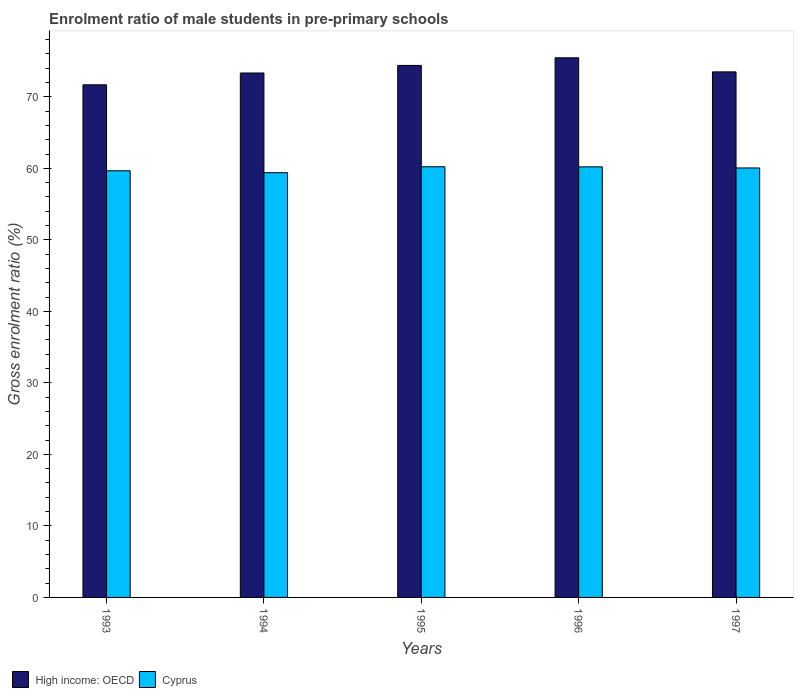Are the number of bars per tick equal to the number of legend labels?
Give a very brief answer. Yes. How many bars are there on the 3rd tick from the right?
Provide a succinct answer. 2. What is the label of the 4th group of bars from the left?
Keep it short and to the point. 1996. In how many cases, is the number of bars for a given year not equal to the number of legend labels?
Your answer should be very brief. 0. What is the enrolment ratio of male students in pre-primary schools in High income: OECD in 1996?
Ensure brevity in your answer.  75.45. Across all years, what is the maximum enrolment ratio of male students in pre-primary schools in Cyprus?
Your answer should be compact. 60.22. Across all years, what is the minimum enrolment ratio of male students in pre-primary schools in Cyprus?
Offer a very short reply. 59.39. In which year was the enrolment ratio of male students in pre-primary schools in Cyprus minimum?
Give a very brief answer. 1994. What is the total enrolment ratio of male students in pre-primary schools in High income: OECD in the graph?
Your answer should be very brief. 368.33. What is the difference between the enrolment ratio of male students in pre-primary schools in Cyprus in 1994 and that in 1995?
Your answer should be compact. -0.83. What is the difference between the enrolment ratio of male students in pre-primary schools in High income: OECD in 1996 and the enrolment ratio of male students in pre-primary schools in Cyprus in 1994?
Your answer should be compact. 16.07. What is the average enrolment ratio of male students in pre-primary schools in High income: OECD per year?
Ensure brevity in your answer.  73.67. In the year 1993, what is the difference between the enrolment ratio of male students in pre-primary schools in Cyprus and enrolment ratio of male students in pre-primary schools in High income: OECD?
Keep it short and to the point. -12.02. In how many years, is the enrolment ratio of male students in pre-primary schools in Cyprus greater than 62 %?
Provide a succinct answer. 0. What is the ratio of the enrolment ratio of male students in pre-primary schools in High income: OECD in 1994 to that in 1995?
Provide a short and direct response. 0.99. Is the enrolment ratio of male students in pre-primary schools in Cyprus in 1993 less than that in 1996?
Offer a terse response. Yes. Is the difference between the enrolment ratio of male students in pre-primary schools in Cyprus in 1994 and 1996 greater than the difference between the enrolment ratio of male students in pre-primary schools in High income: OECD in 1994 and 1996?
Give a very brief answer. Yes. What is the difference between the highest and the second highest enrolment ratio of male students in pre-primary schools in Cyprus?
Provide a succinct answer. 0.01. What is the difference between the highest and the lowest enrolment ratio of male students in pre-primary schools in High income: OECD?
Provide a short and direct response. 3.77. What does the 1st bar from the left in 1993 represents?
Ensure brevity in your answer.  High income: OECD. What does the 2nd bar from the right in 1993 represents?
Keep it short and to the point. High income: OECD. How many bars are there?
Offer a terse response. 10. Are all the bars in the graph horizontal?
Your answer should be compact. No. What is the difference between two consecutive major ticks on the Y-axis?
Offer a very short reply. 10. Does the graph contain any zero values?
Offer a very short reply. No. Does the graph contain grids?
Give a very brief answer. No. Where does the legend appear in the graph?
Your answer should be very brief. Bottom left. How many legend labels are there?
Keep it short and to the point. 2. What is the title of the graph?
Offer a terse response. Enrolment ratio of male students in pre-primary schools. Does "Samoa" appear as one of the legend labels in the graph?
Give a very brief answer. No. What is the Gross enrolment ratio (%) in High income: OECD in 1993?
Provide a short and direct response. 71.68. What is the Gross enrolment ratio (%) of Cyprus in 1993?
Give a very brief answer. 59.66. What is the Gross enrolment ratio (%) in High income: OECD in 1994?
Your answer should be compact. 73.33. What is the Gross enrolment ratio (%) of Cyprus in 1994?
Ensure brevity in your answer.  59.39. What is the Gross enrolment ratio (%) in High income: OECD in 1995?
Keep it short and to the point. 74.39. What is the Gross enrolment ratio (%) in Cyprus in 1995?
Your answer should be compact. 60.22. What is the Gross enrolment ratio (%) of High income: OECD in 1996?
Provide a succinct answer. 75.45. What is the Gross enrolment ratio (%) of Cyprus in 1996?
Your answer should be compact. 60.2. What is the Gross enrolment ratio (%) in High income: OECD in 1997?
Your answer should be compact. 73.49. What is the Gross enrolment ratio (%) of Cyprus in 1997?
Keep it short and to the point. 60.05. Across all years, what is the maximum Gross enrolment ratio (%) of High income: OECD?
Provide a short and direct response. 75.45. Across all years, what is the maximum Gross enrolment ratio (%) in Cyprus?
Make the answer very short. 60.22. Across all years, what is the minimum Gross enrolment ratio (%) in High income: OECD?
Give a very brief answer. 71.68. Across all years, what is the minimum Gross enrolment ratio (%) in Cyprus?
Make the answer very short. 59.39. What is the total Gross enrolment ratio (%) in High income: OECD in the graph?
Your answer should be compact. 368.33. What is the total Gross enrolment ratio (%) of Cyprus in the graph?
Your response must be concise. 299.51. What is the difference between the Gross enrolment ratio (%) of High income: OECD in 1993 and that in 1994?
Your answer should be very brief. -1.65. What is the difference between the Gross enrolment ratio (%) of Cyprus in 1993 and that in 1994?
Your response must be concise. 0.27. What is the difference between the Gross enrolment ratio (%) in High income: OECD in 1993 and that in 1995?
Keep it short and to the point. -2.71. What is the difference between the Gross enrolment ratio (%) in Cyprus in 1993 and that in 1995?
Your answer should be compact. -0.56. What is the difference between the Gross enrolment ratio (%) in High income: OECD in 1993 and that in 1996?
Make the answer very short. -3.77. What is the difference between the Gross enrolment ratio (%) of Cyprus in 1993 and that in 1996?
Ensure brevity in your answer.  -0.55. What is the difference between the Gross enrolment ratio (%) in High income: OECD in 1993 and that in 1997?
Provide a succinct answer. -1.81. What is the difference between the Gross enrolment ratio (%) of Cyprus in 1993 and that in 1997?
Your answer should be very brief. -0.39. What is the difference between the Gross enrolment ratio (%) of High income: OECD in 1994 and that in 1995?
Provide a short and direct response. -1.06. What is the difference between the Gross enrolment ratio (%) of Cyprus in 1994 and that in 1995?
Provide a short and direct response. -0.83. What is the difference between the Gross enrolment ratio (%) of High income: OECD in 1994 and that in 1996?
Your answer should be compact. -2.12. What is the difference between the Gross enrolment ratio (%) of Cyprus in 1994 and that in 1996?
Provide a short and direct response. -0.82. What is the difference between the Gross enrolment ratio (%) of High income: OECD in 1994 and that in 1997?
Give a very brief answer. -0.16. What is the difference between the Gross enrolment ratio (%) of Cyprus in 1994 and that in 1997?
Your answer should be compact. -0.66. What is the difference between the Gross enrolment ratio (%) in High income: OECD in 1995 and that in 1996?
Ensure brevity in your answer.  -1.06. What is the difference between the Gross enrolment ratio (%) of Cyprus in 1995 and that in 1996?
Make the answer very short. 0.01. What is the difference between the Gross enrolment ratio (%) in High income: OECD in 1995 and that in 1997?
Ensure brevity in your answer.  0.9. What is the difference between the Gross enrolment ratio (%) of Cyprus in 1995 and that in 1997?
Keep it short and to the point. 0.17. What is the difference between the Gross enrolment ratio (%) in High income: OECD in 1996 and that in 1997?
Provide a succinct answer. 1.97. What is the difference between the Gross enrolment ratio (%) of Cyprus in 1996 and that in 1997?
Provide a succinct answer. 0.15. What is the difference between the Gross enrolment ratio (%) of High income: OECD in 1993 and the Gross enrolment ratio (%) of Cyprus in 1994?
Offer a very short reply. 12.29. What is the difference between the Gross enrolment ratio (%) of High income: OECD in 1993 and the Gross enrolment ratio (%) of Cyprus in 1995?
Your answer should be very brief. 11.46. What is the difference between the Gross enrolment ratio (%) of High income: OECD in 1993 and the Gross enrolment ratio (%) of Cyprus in 1996?
Your answer should be compact. 11.47. What is the difference between the Gross enrolment ratio (%) of High income: OECD in 1993 and the Gross enrolment ratio (%) of Cyprus in 1997?
Make the answer very short. 11.63. What is the difference between the Gross enrolment ratio (%) in High income: OECD in 1994 and the Gross enrolment ratio (%) in Cyprus in 1995?
Make the answer very short. 13.11. What is the difference between the Gross enrolment ratio (%) of High income: OECD in 1994 and the Gross enrolment ratio (%) of Cyprus in 1996?
Ensure brevity in your answer.  13.12. What is the difference between the Gross enrolment ratio (%) of High income: OECD in 1994 and the Gross enrolment ratio (%) of Cyprus in 1997?
Ensure brevity in your answer.  13.28. What is the difference between the Gross enrolment ratio (%) of High income: OECD in 1995 and the Gross enrolment ratio (%) of Cyprus in 1996?
Offer a very short reply. 14.19. What is the difference between the Gross enrolment ratio (%) in High income: OECD in 1995 and the Gross enrolment ratio (%) in Cyprus in 1997?
Your answer should be very brief. 14.34. What is the difference between the Gross enrolment ratio (%) of High income: OECD in 1996 and the Gross enrolment ratio (%) of Cyprus in 1997?
Your response must be concise. 15.4. What is the average Gross enrolment ratio (%) of High income: OECD per year?
Make the answer very short. 73.67. What is the average Gross enrolment ratio (%) of Cyprus per year?
Make the answer very short. 59.9. In the year 1993, what is the difference between the Gross enrolment ratio (%) in High income: OECD and Gross enrolment ratio (%) in Cyprus?
Provide a succinct answer. 12.02. In the year 1994, what is the difference between the Gross enrolment ratio (%) of High income: OECD and Gross enrolment ratio (%) of Cyprus?
Keep it short and to the point. 13.94. In the year 1995, what is the difference between the Gross enrolment ratio (%) of High income: OECD and Gross enrolment ratio (%) of Cyprus?
Provide a succinct answer. 14.17. In the year 1996, what is the difference between the Gross enrolment ratio (%) in High income: OECD and Gross enrolment ratio (%) in Cyprus?
Provide a short and direct response. 15.25. In the year 1997, what is the difference between the Gross enrolment ratio (%) of High income: OECD and Gross enrolment ratio (%) of Cyprus?
Your answer should be compact. 13.44. What is the ratio of the Gross enrolment ratio (%) of High income: OECD in 1993 to that in 1994?
Offer a terse response. 0.98. What is the ratio of the Gross enrolment ratio (%) in High income: OECD in 1993 to that in 1995?
Provide a short and direct response. 0.96. What is the ratio of the Gross enrolment ratio (%) of High income: OECD in 1993 to that in 1996?
Provide a succinct answer. 0.95. What is the ratio of the Gross enrolment ratio (%) of Cyprus in 1993 to that in 1996?
Give a very brief answer. 0.99. What is the ratio of the Gross enrolment ratio (%) of High income: OECD in 1993 to that in 1997?
Give a very brief answer. 0.98. What is the ratio of the Gross enrolment ratio (%) of Cyprus in 1993 to that in 1997?
Provide a succinct answer. 0.99. What is the ratio of the Gross enrolment ratio (%) of High income: OECD in 1994 to that in 1995?
Ensure brevity in your answer.  0.99. What is the ratio of the Gross enrolment ratio (%) in Cyprus in 1994 to that in 1995?
Offer a terse response. 0.99. What is the ratio of the Gross enrolment ratio (%) in High income: OECD in 1994 to that in 1996?
Offer a very short reply. 0.97. What is the ratio of the Gross enrolment ratio (%) in Cyprus in 1994 to that in 1996?
Offer a terse response. 0.99. What is the ratio of the Gross enrolment ratio (%) of High income: OECD in 1994 to that in 1997?
Provide a succinct answer. 1. What is the ratio of the Gross enrolment ratio (%) of Cyprus in 1994 to that in 1997?
Your response must be concise. 0.99. What is the ratio of the Gross enrolment ratio (%) of High income: OECD in 1995 to that in 1996?
Your answer should be very brief. 0.99. What is the ratio of the Gross enrolment ratio (%) in Cyprus in 1995 to that in 1996?
Make the answer very short. 1. What is the ratio of the Gross enrolment ratio (%) in High income: OECD in 1995 to that in 1997?
Offer a very short reply. 1.01. What is the ratio of the Gross enrolment ratio (%) in Cyprus in 1995 to that in 1997?
Provide a short and direct response. 1. What is the ratio of the Gross enrolment ratio (%) in High income: OECD in 1996 to that in 1997?
Your response must be concise. 1.03. What is the difference between the highest and the second highest Gross enrolment ratio (%) in High income: OECD?
Offer a terse response. 1.06. What is the difference between the highest and the second highest Gross enrolment ratio (%) in Cyprus?
Provide a short and direct response. 0.01. What is the difference between the highest and the lowest Gross enrolment ratio (%) in High income: OECD?
Offer a very short reply. 3.77. What is the difference between the highest and the lowest Gross enrolment ratio (%) in Cyprus?
Make the answer very short. 0.83. 